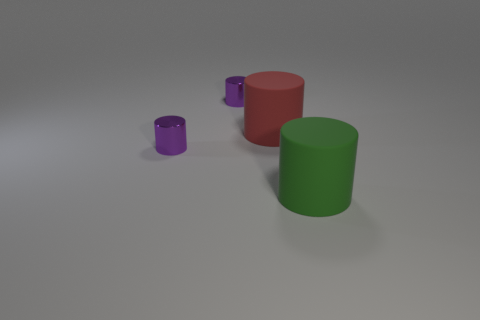How many cyan objects are cylinders or metal cylinders?
Make the answer very short. 0. There is a large cylinder behind the big green matte thing; what is its material?
Give a very brief answer. Rubber. Are the big red cylinder left of the green cylinder and the green thing made of the same material?
Make the answer very short. Yes. The red object is what shape?
Offer a terse response. Cylinder. There is a small shiny object behind the rubber cylinder that is behind the green matte cylinder; what number of tiny purple cylinders are in front of it?
Offer a terse response. 1. What number of other objects are the same material as the big green cylinder?
Offer a very short reply. 1. There is a red cylinder that is the same size as the green cylinder; what is its material?
Ensure brevity in your answer.  Rubber. Do the matte object behind the green rubber thing and the metallic cylinder in front of the large red object have the same color?
Provide a succinct answer. No. Is there a small blue thing that has the same shape as the big green thing?
Your answer should be compact. No. What shape is the red matte thing that is the same size as the green cylinder?
Ensure brevity in your answer.  Cylinder. 